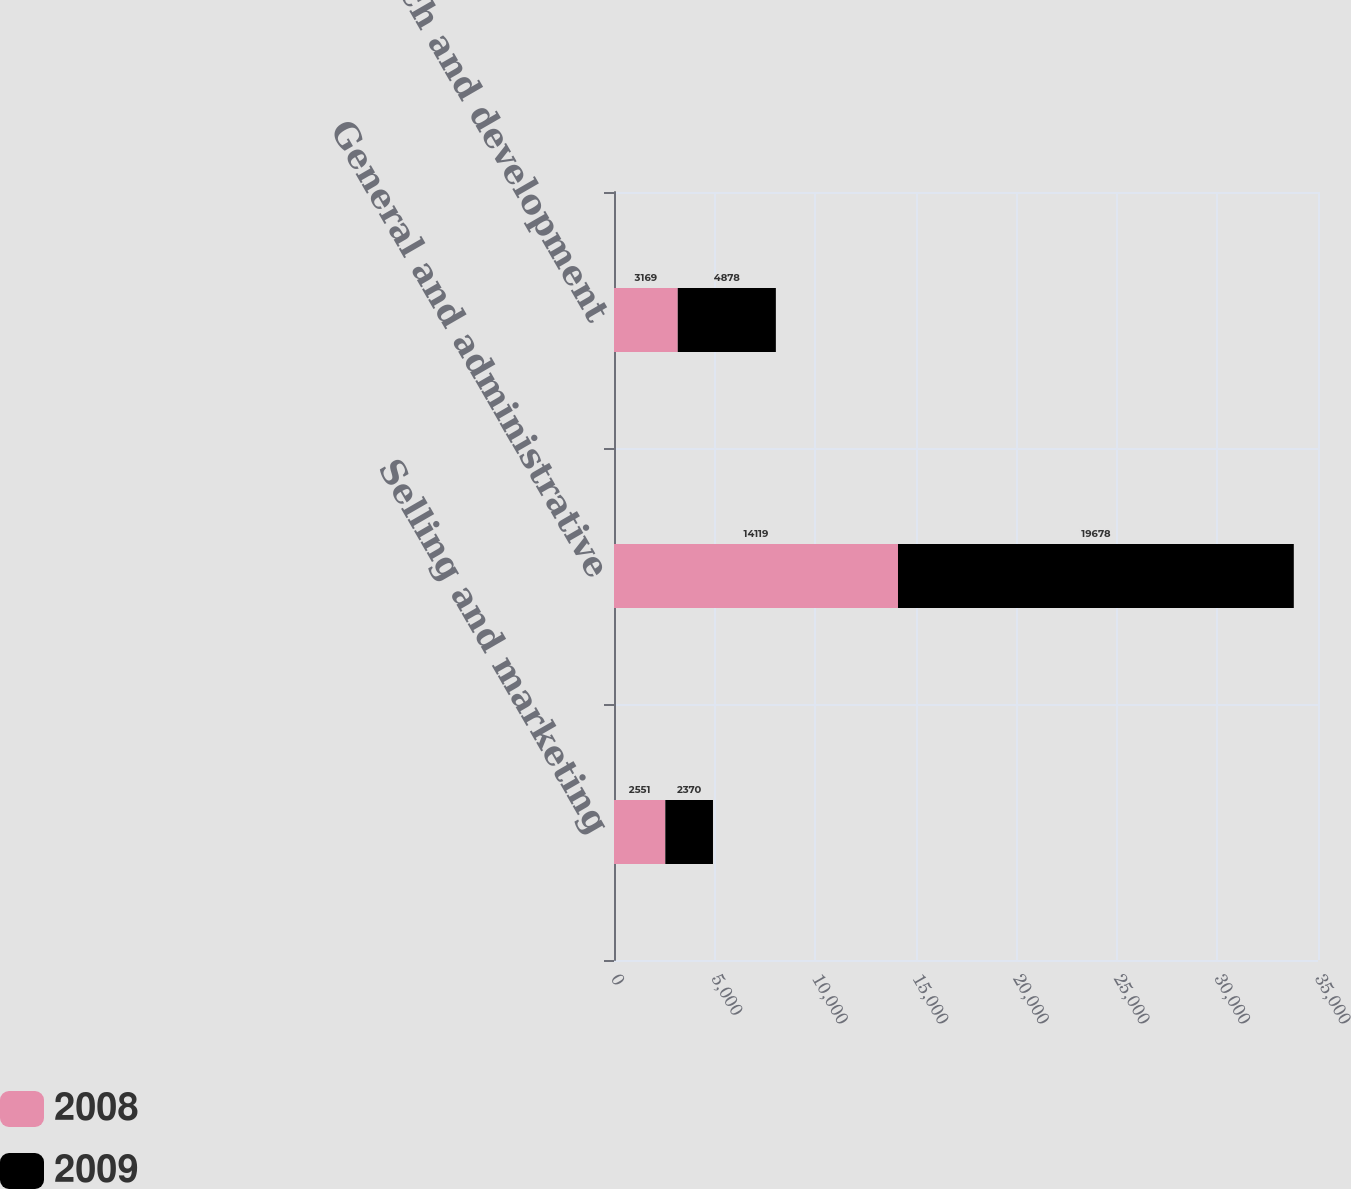Convert chart to OTSL. <chart><loc_0><loc_0><loc_500><loc_500><stacked_bar_chart><ecel><fcel>Selling and marketing<fcel>General and administrative<fcel>Research and development<nl><fcel>2008<fcel>2551<fcel>14119<fcel>3169<nl><fcel>2009<fcel>2370<fcel>19678<fcel>4878<nl></chart> 